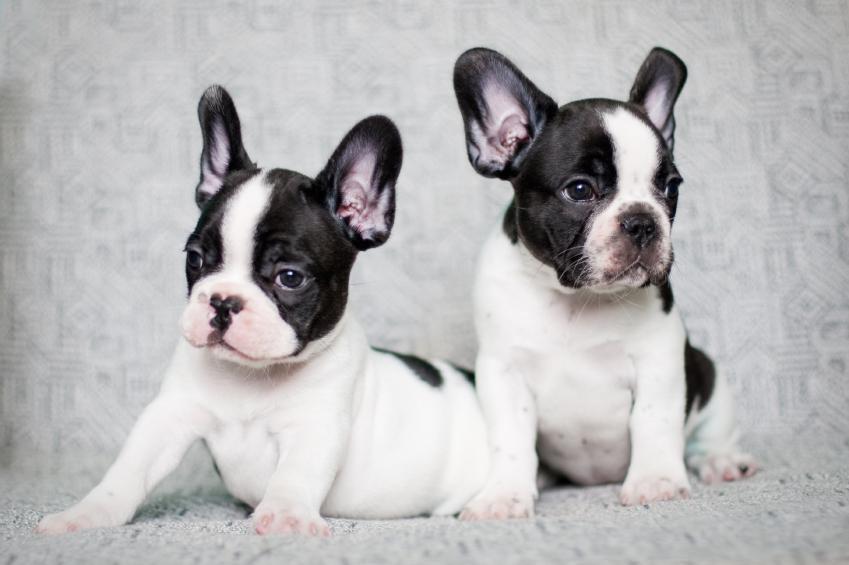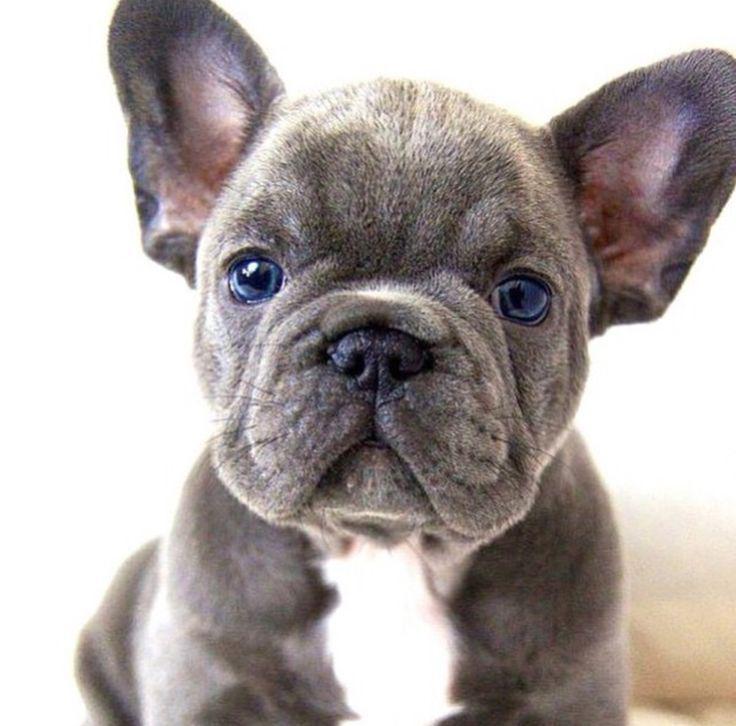The first image is the image on the left, the second image is the image on the right. For the images displayed, is the sentence "There are two dogs" factually correct? Answer yes or no. No. The first image is the image on the left, the second image is the image on the right. Considering the images on both sides, is "There are two dogs shown in total." valid? Answer yes or no. No. 